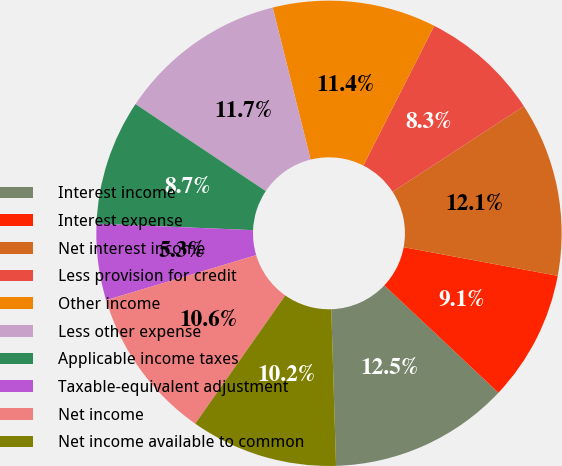<chart> <loc_0><loc_0><loc_500><loc_500><pie_chart><fcel>Interest income<fcel>Interest expense<fcel>Net interest income<fcel>Less provision for credit<fcel>Other income<fcel>Less other expense<fcel>Applicable income taxes<fcel>Taxable-equivalent adjustment<fcel>Net income<fcel>Net income available to common<nl><fcel>12.5%<fcel>9.09%<fcel>12.12%<fcel>8.33%<fcel>11.36%<fcel>11.74%<fcel>8.71%<fcel>5.3%<fcel>10.61%<fcel>10.23%<nl></chart> 